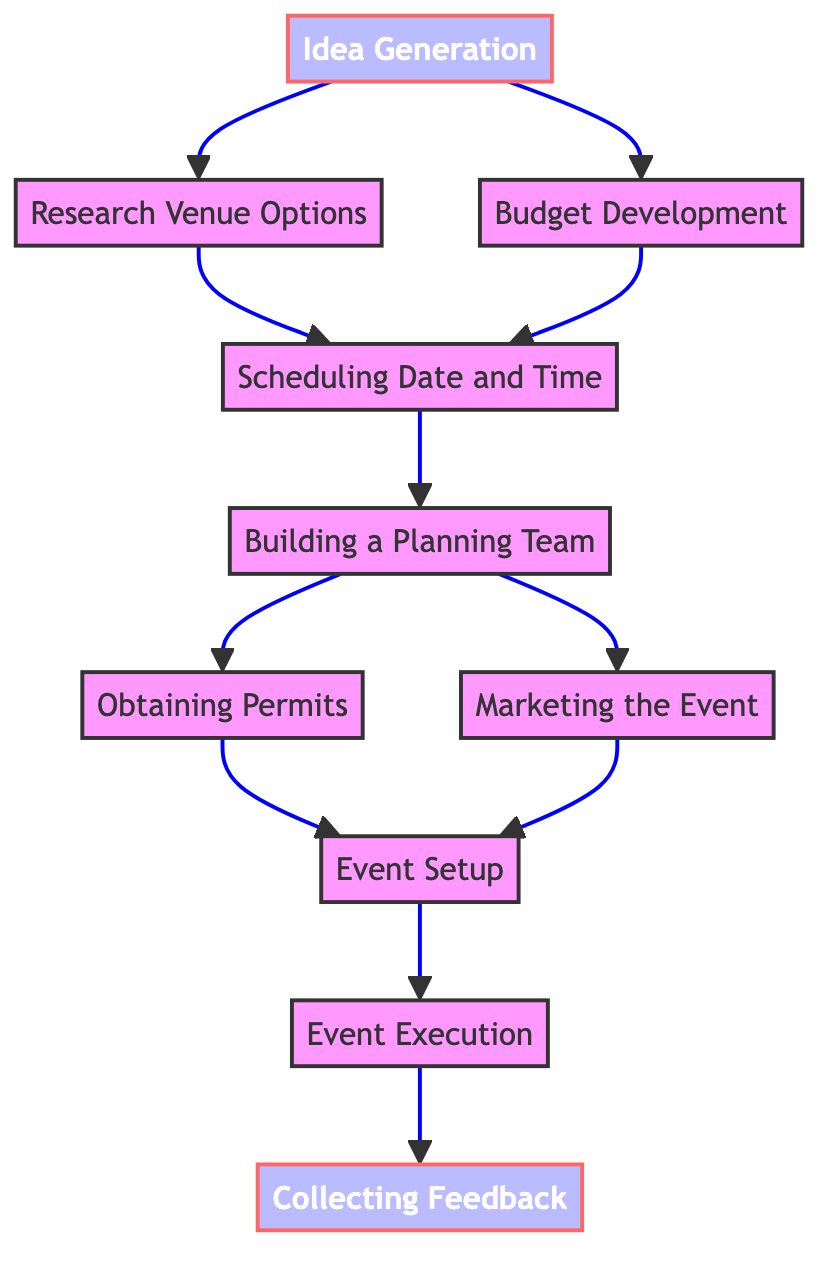What is the first step in the process? The first step according to the diagram is "Idea Generation." It is the starting point and has outgoing edges leading to the next two tasks: "Research Venue Options" and "Budget Development."
Answer: Idea Generation How many total nodes are present in the diagram? By counting the individual nodes listed in the diagram, we find ten nodes: Idea Generation, Research Venue Options, Budget Development, Scheduling Date and Time, Building a Planning Team, Obtaining Permits, Marketing the Event, Event Setup, Event Execution, and Collecting Feedback.
Answer: 10 Which task comes after "Team Building"? The task that follows "Team Building" is "Obtaining Permits" and "Marketing the Event." The edges leading from "Team Building" indicate that both "Obtaining Permits" and "Marketing the Event" can occur as subsequent tasks.
Answer: Obtaining Permits, Marketing the Event What is the relationship between "Budget Development" and "Scheduling Date and Time"? The relationship demonstrated in the diagram shows that both "Budget Development" and "Research Venue Options" lead to "Scheduling Date and Time." This indicates that both tasks must be completed before scheduling can happen.
Answer: Both lead to Scheduling Date and Time What is the last step in the sequence? The last step indicated in the diagram is "Collecting Feedback," which follows "Event Execution." The structure of the diagram suggests that feedback is collected after the event has taken place.
Answer: Collecting Feedback What tasks must be completed before the "Setup"? "Obtaining Permits" and "Marketing the Event" are both prerequisites for "Event Setup." The edges going into "Event Setup" show that these two tasks need to be completed first.
Answer: Obtaining Permits, Marketing the Event Which task requires both permits and marketing? According to the diagram, the task "Event Setup" requires both "Obtaining Permits" and "Marketing the Event" as prerequisites, indicating that both are necessary before setting up the event.
Answer: Event Setup How many edges are there in the diagram? By counting the connections between the nodes illustrated in the diagram, we find a total of eleven edges. Each edge represents a transition or flow from one task to another.
Answer: 11 What is the connection pattern going from "Execution" to "Feedback"? The connection pattern from "Execution" to "Feedback" is direct; it is the final step in the process where feedback is collected after the event has been executed.
Answer: Direct connection 